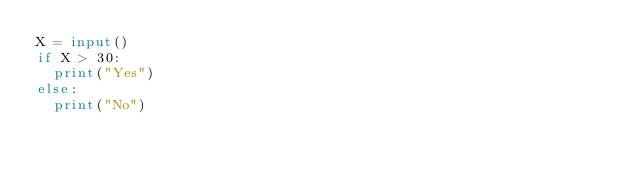Convert code to text. <code><loc_0><loc_0><loc_500><loc_500><_Python_>X = input()
if X > 30:
  print("Yes")
else:
  print("No")</code> 